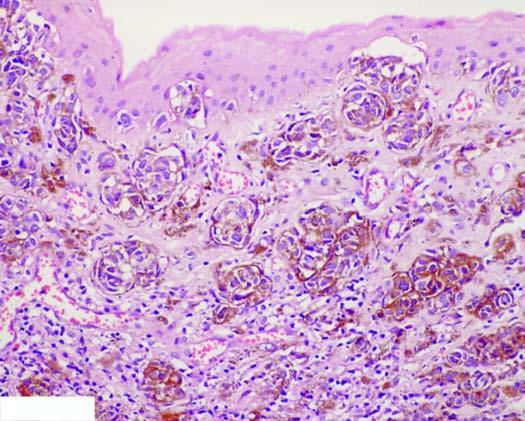what do these cells contain?
Answer the question using a single word or phrase. Coarse 